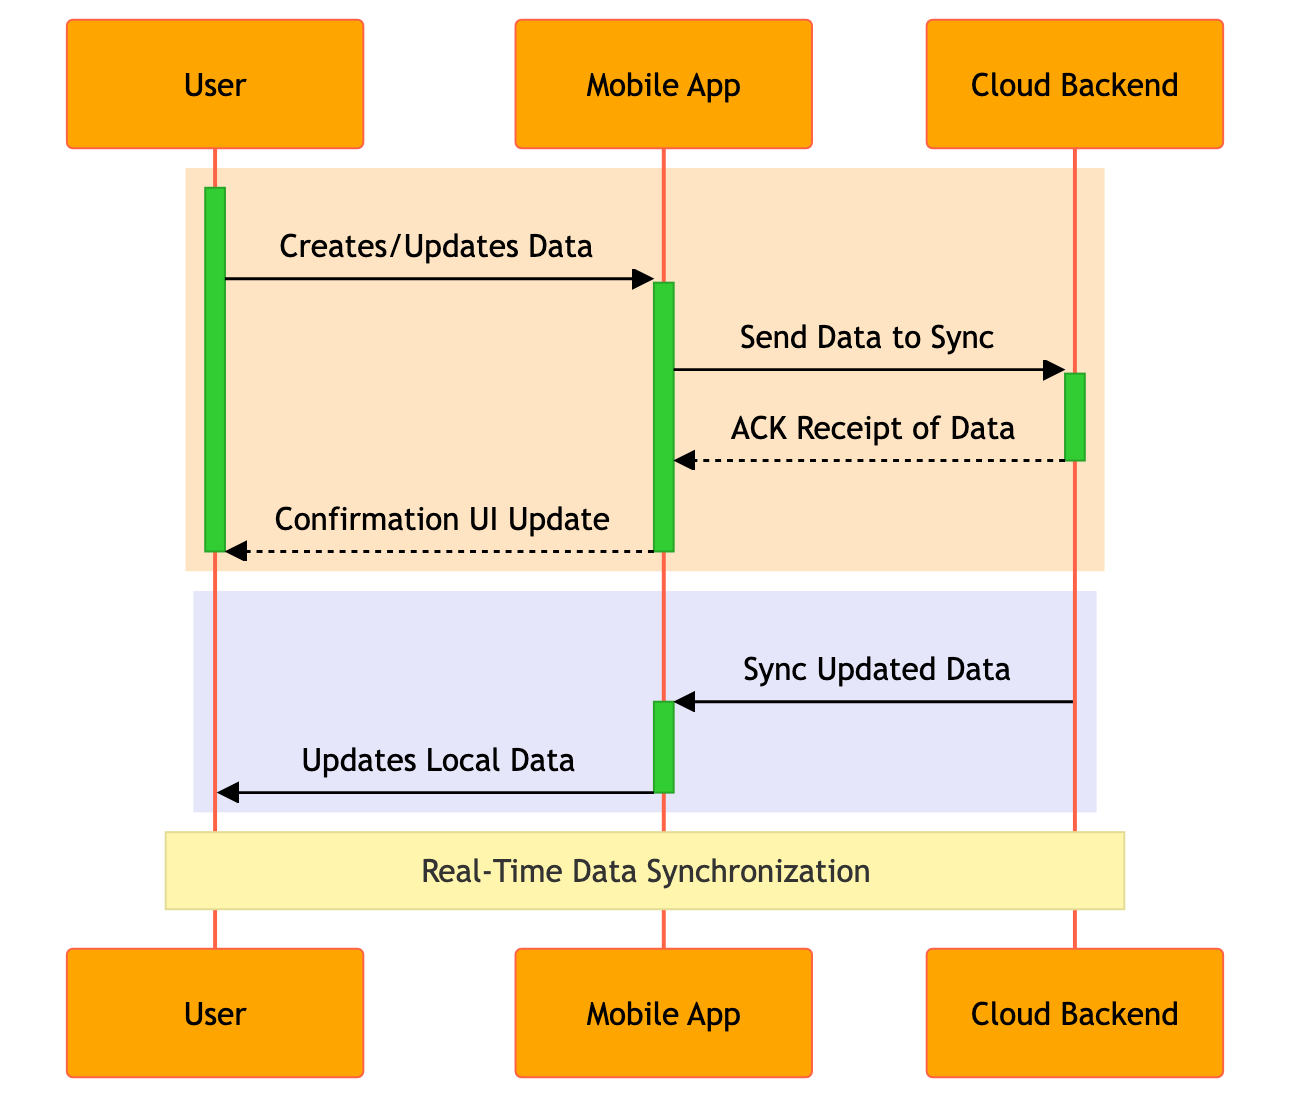What is the first action taken by the User? The diagram indicates that the first action taken by the User is "Creates/Updates Data". This is seen as the initial message from the User to the Mobile App.
Answer: Creates/Updates Data How many participants are involved in the sequence? The participants listed in the diagram are User, Mobile App, and Cloud Backend, totaling three participants.
Answer: 3 What message does the Mobile App send to the Cloud Backend? According to the diagram, the message sent from the Mobile App to the Cloud Backend is "Send Data to Sync". This is detailed in the message flow between the two participants.
Answer: Send Data to Sync Which participant acknowledges the receipt of data? The Cloud Backend is the participant that acknowledges the receipt of data by sending an "ACK Receipt of Data" back to the Mobile App. This is shown in the sequence of messages exchanged.
Answer: Cloud Backend What is the last action performed by the Mobile App? The last action performed by the Mobile App, as shown in the diagram, is "Updates Local Data", which is sent to the User after the Cloud Backend syncs updated data.
Answer: Updates Local Data How many messages are exchanged between the User and the Mobile App? There are a total of three messages exchanged between the User and the Mobile App: "Creates/Updates Data", "Confirmation UI Update", and "Updates Local Data". Counting these events results in three messages.
Answer: 3 What is the purpose of the note over the diagram? The note over the diagram mentions "Real-Time Data Synchronization", indicating the overall purpose of the sequence diagram, which is to illustrate the process of synchronizing data in real time between the Mobile App and Cloud Backend.
Answer: Real-Time Data Synchronization What does the Cloud Backend send to the Mobile App after it receives the data? The Cloud Backend sends a message to the Mobile App titled "Sync Updated Data" after it acknowledges receipt of the data. This indicates the next step in the synchronization process.
Answer: Sync Updated Data Which two actions are activated simultaneously in the diagram? The activation bars for the Mobile App and Cloud Backend overlap during the "Send Data to Sync" and "Sync Updated Data" messaging. This indicates that both are active simultaneously during these actions.
Answer: Send Data to Sync, Sync Updated Data 